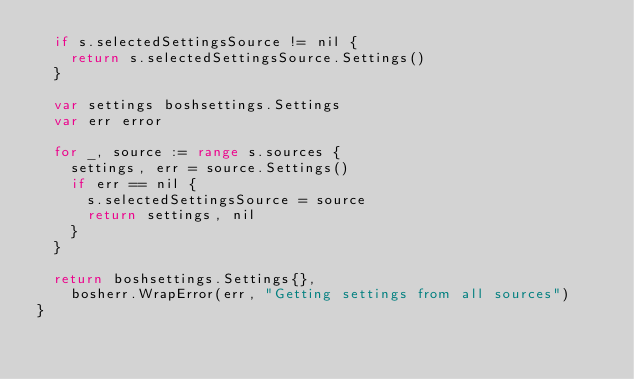Convert code to text. <code><loc_0><loc_0><loc_500><loc_500><_Go_>	if s.selectedSettingsSource != nil {
		return s.selectedSettingsSource.Settings()
	}

	var settings boshsettings.Settings
	var err error

	for _, source := range s.sources {
		settings, err = source.Settings()
		if err == nil {
			s.selectedSettingsSource = source
			return settings, nil
		}
	}

	return boshsettings.Settings{},
		bosherr.WrapError(err, "Getting settings from all sources")
}
</code> 